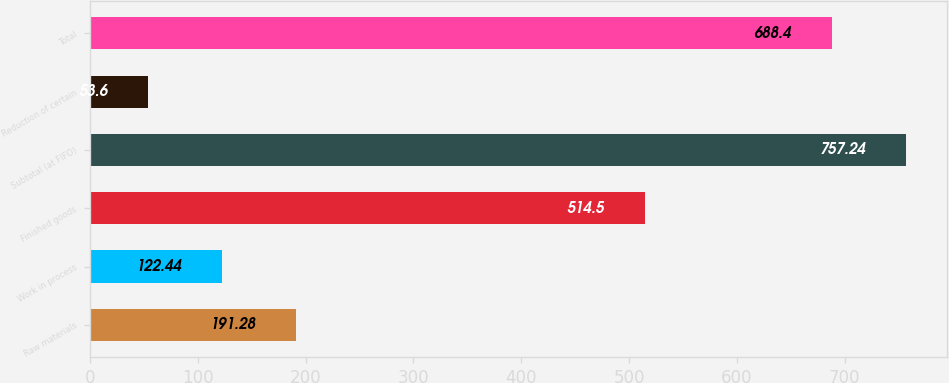<chart> <loc_0><loc_0><loc_500><loc_500><bar_chart><fcel>Raw materials<fcel>Work in process<fcel>Finished goods<fcel>Subtotal (at FIFO)<fcel>Reduction of certain<fcel>Total<nl><fcel>191.28<fcel>122.44<fcel>514.5<fcel>757.24<fcel>53.6<fcel>688.4<nl></chart> 